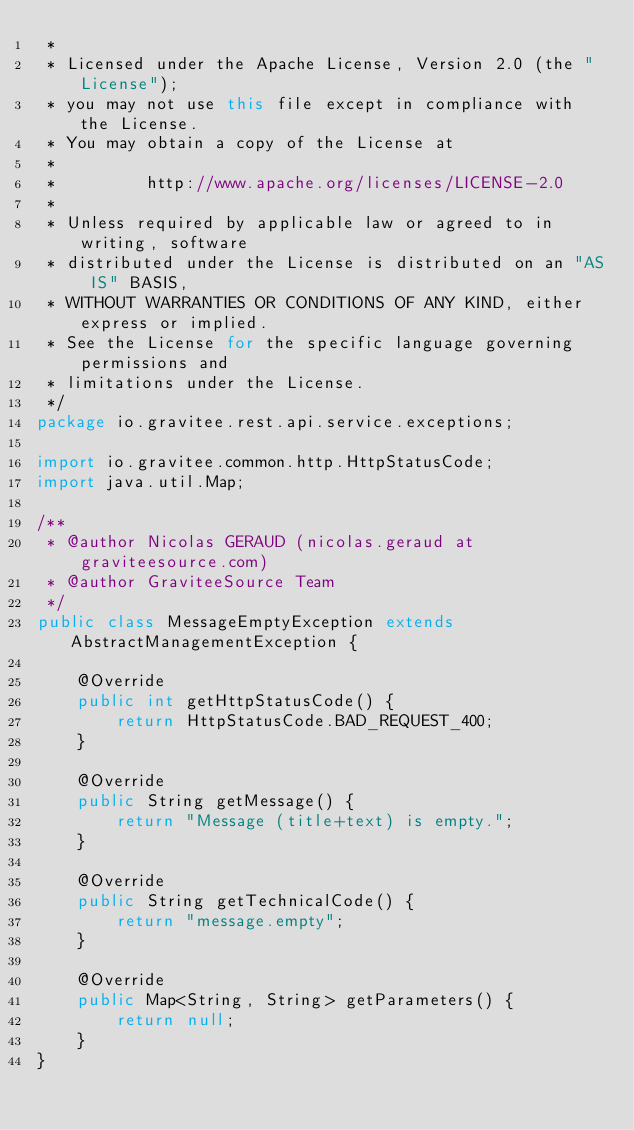<code> <loc_0><loc_0><loc_500><loc_500><_Java_> *
 * Licensed under the Apache License, Version 2.0 (the "License");
 * you may not use this file except in compliance with the License.
 * You may obtain a copy of the License at
 *
 *         http://www.apache.org/licenses/LICENSE-2.0
 *
 * Unless required by applicable law or agreed to in writing, software
 * distributed under the License is distributed on an "AS IS" BASIS,
 * WITHOUT WARRANTIES OR CONDITIONS OF ANY KIND, either express or implied.
 * See the License for the specific language governing permissions and
 * limitations under the License.
 */
package io.gravitee.rest.api.service.exceptions;

import io.gravitee.common.http.HttpStatusCode;
import java.util.Map;

/**
 * @author Nicolas GERAUD (nicolas.geraud at graviteesource.com)
 * @author GraviteeSource Team
 */
public class MessageEmptyException extends AbstractManagementException {

    @Override
    public int getHttpStatusCode() {
        return HttpStatusCode.BAD_REQUEST_400;
    }

    @Override
    public String getMessage() {
        return "Message (title+text) is empty.";
    }

    @Override
    public String getTechnicalCode() {
        return "message.empty";
    }

    @Override
    public Map<String, String> getParameters() {
        return null;
    }
}
</code> 